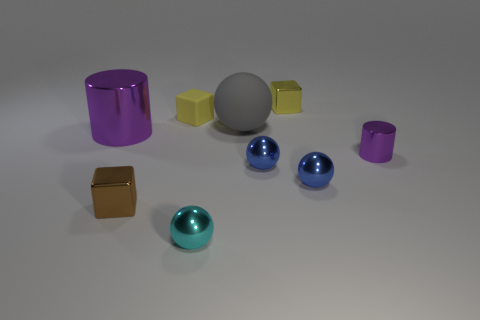Add 1 tiny brown metallic things. How many objects exist? 10 Subtract 0 green spheres. How many objects are left? 9 Subtract all cubes. How many objects are left? 6 Subtract all small blue objects. Subtract all cylinders. How many objects are left? 5 Add 2 matte cubes. How many matte cubes are left? 3 Add 4 tiny cyan metal things. How many tiny cyan metal things exist? 5 